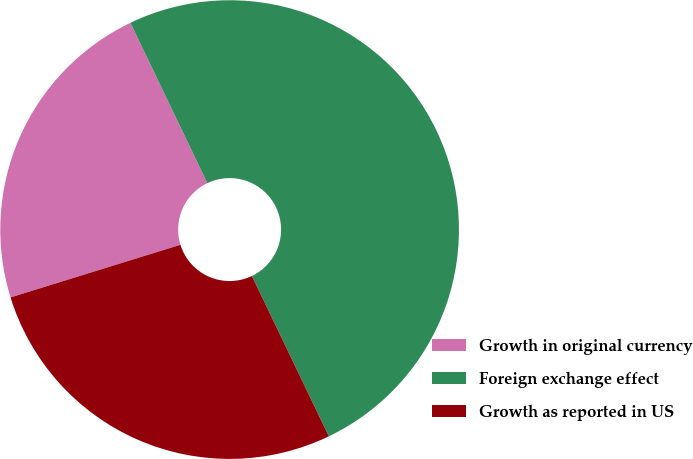Convert chart to OTSL. <chart><loc_0><loc_0><loc_500><loc_500><pie_chart><fcel>Growth in original currency<fcel>Foreign exchange effect<fcel>Growth as reported in US<nl><fcel>22.66%<fcel>50.0%<fcel>27.34%<nl></chart> 